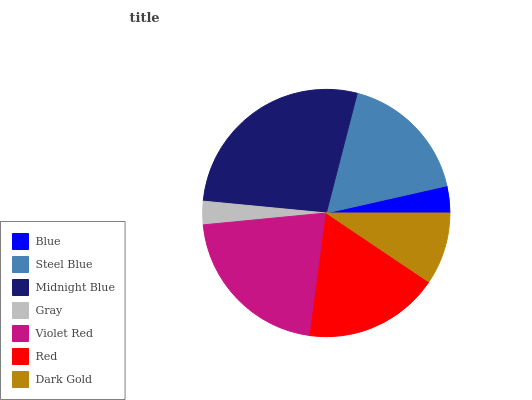Is Gray the minimum?
Answer yes or no. Yes. Is Midnight Blue the maximum?
Answer yes or no. Yes. Is Steel Blue the minimum?
Answer yes or no. No. Is Steel Blue the maximum?
Answer yes or no. No. Is Steel Blue greater than Blue?
Answer yes or no. Yes. Is Blue less than Steel Blue?
Answer yes or no. Yes. Is Blue greater than Steel Blue?
Answer yes or no. No. Is Steel Blue less than Blue?
Answer yes or no. No. Is Steel Blue the high median?
Answer yes or no. Yes. Is Steel Blue the low median?
Answer yes or no. Yes. Is Dark Gold the high median?
Answer yes or no. No. Is Gray the low median?
Answer yes or no. No. 